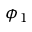Convert formula to latex. <formula><loc_0><loc_0><loc_500><loc_500>\phi _ { 1 }</formula> 